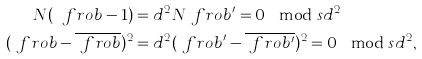Convert formula to latex. <formula><loc_0><loc_0><loc_500><loc_500>N ( \ f r o b - 1 ) & = d ^ { 2 } N \ f r o b ^ { \prime } = 0 \mod s { d ^ { 2 } } \\ ( \ f r o b - \overline { \ f r o b } ) ^ { 2 } & = d ^ { 2 } ( \ f r o b ^ { \prime } - \overline { \ f r o b ^ { \prime } } ) ^ { 2 } = 0 \mod s { d ^ { 2 } } ,</formula> 